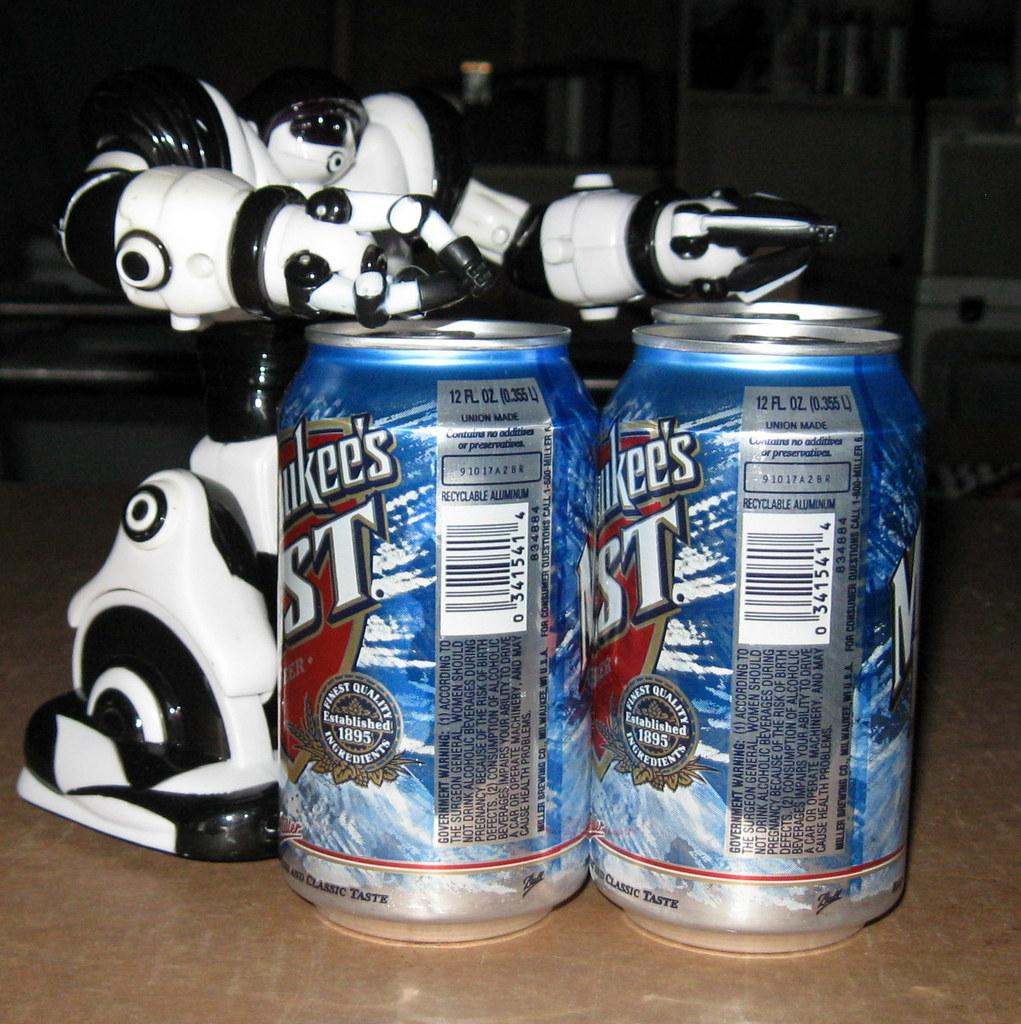<image>
Relay a brief, clear account of the picture shown. Two cans of Milwaukees Best beer with a robot 